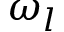<formula> <loc_0><loc_0><loc_500><loc_500>\omega _ { l }</formula> 